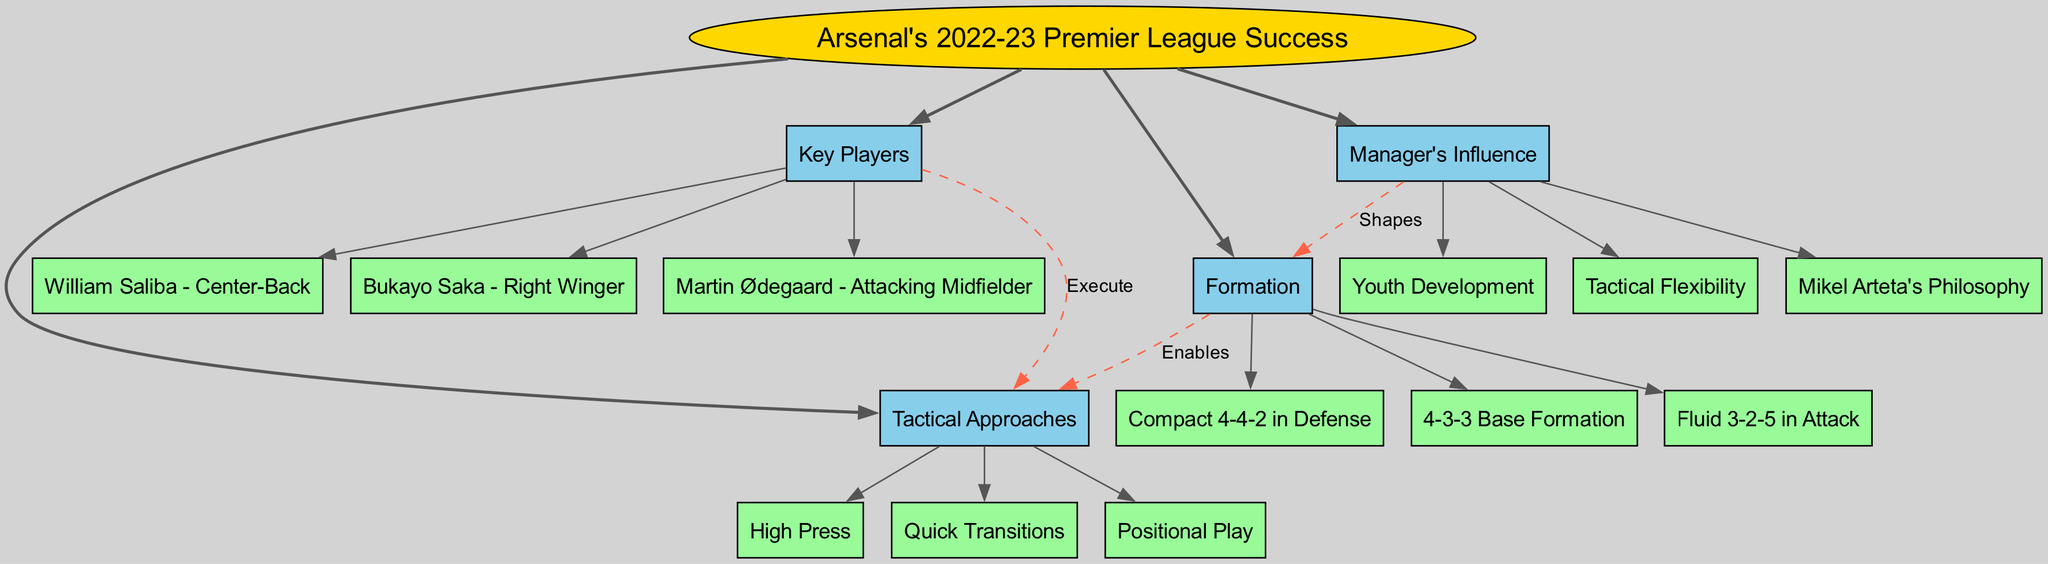What is the central topic of the diagram? The central topic is labeled at the center of the diagram, specifically mentioned as "Arsenal's 2022-23 Premier League Success."
Answer: Arsenal's 2022-23 Premier League Success How many main branches are there in the diagram? Each main branch is directly connected to the central topic, and counting those gives a total of four main branches.
Answer: 4 What formation does the underdog team primarily use? The formation branch directly lists the "4-3-3 Base Formation" as its first sub-branch, indicating that this is the primary formation used.
Answer: 4-3-3 Base Formation Which tactical approach is used to transition quickly in play? The "Quick Transitions" sub-branch is included under the "Tactical Approaches" main branch and directly represents this aspect of their playing style.
Answer: Quick Transitions What key player is identified as the Right Winger? The "Key Players" branch includes the sub-branch "Bukayo Saka - Right Winger," which identifies this specific player in that position.
Answer: Bukayo Saka How does the manager influence the team's formation? The connection between "Manager's Influence" and "Formation" is labeled "Shapes," indicating that the manager's decisions significantly shape the formation used by the team.
Answer: Shapes Which tactical approach is executed by the key players? The connection labeled "Execute" between the "Key Players" and "Tactical Approaches" branches indicates that the tactical approaches are carried out by these key players.
Answer: Execute What is the tactical philosophy of Mikel Arteta represented as? This is represented in the "Manager's Influence" branch and includes "Mikel Arteta's Philosophy" as a sub-branch, showcasing that his philosophy influences the team.
Answer: Mikel Arteta's Philosophy How many sub-branches are there under the "Tactical Approaches" branch? The sub-branches under "Tactical Approaches" comprise three distinct tactics: "High Press," "Quick Transitions," and "Positional Play."
Answer: 3 